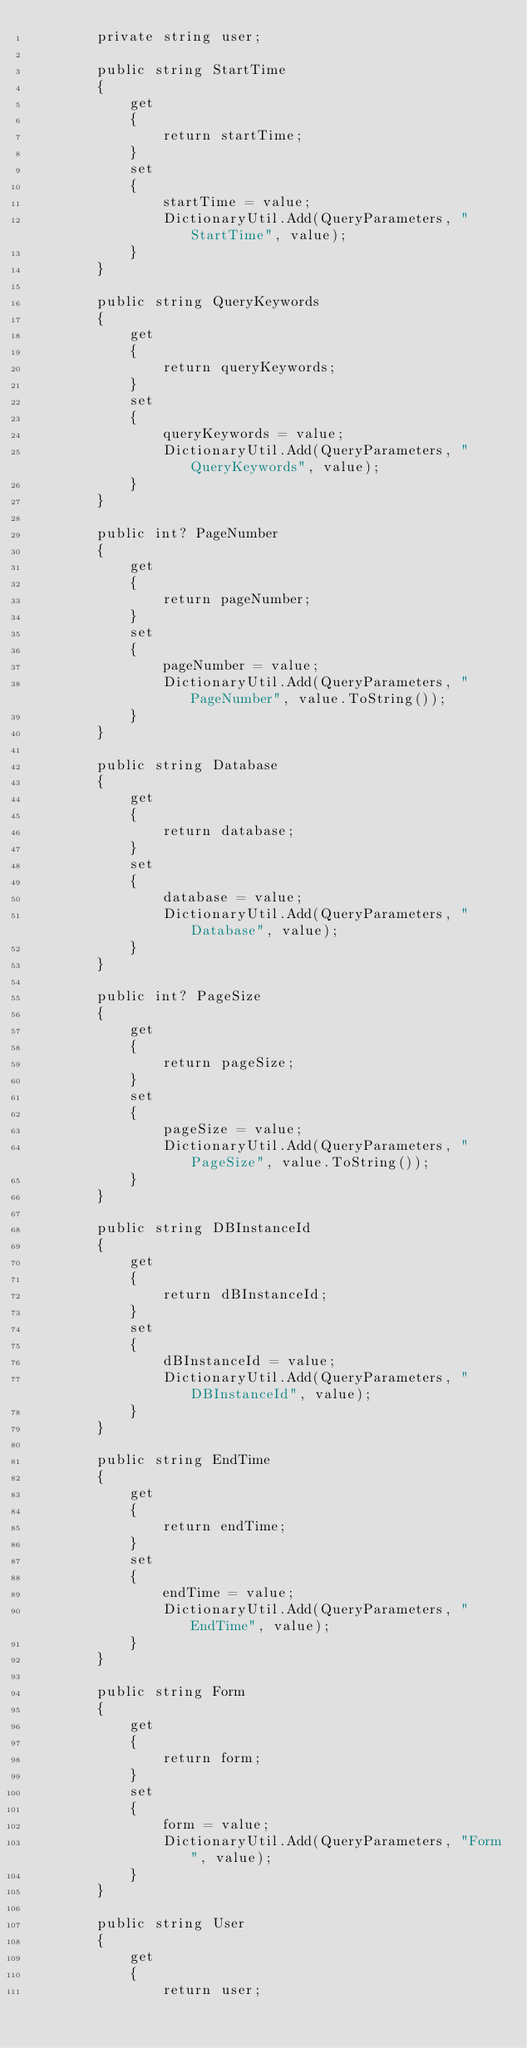<code> <loc_0><loc_0><loc_500><loc_500><_C#_>		private string user;

		public string StartTime
		{
			get
			{
				return startTime;
			}
			set	
			{
				startTime = value;
				DictionaryUtil.Add(QueryParameters, "StartTime", value);
			}
		}

		public string QueryKeywords
		{
			get
			{
				return queryKeywords;
			}
			set	
			{
				queryKeywords = value;
				DictionaryUtil.Add(QueryParameters, "QueryKeywords", value);
			}
		}

		public int? PageNumber
		{
			get
			{
				return pageNumber;
			}
			set	
			{
				pageNumber = value;
				DictionaryUtil.Add(QueryParameters, "PageNumber", value.ToString());
			}
		}

		public string Database
		{
			get
			{
				return database;
			}
			set	
			{
				database = value;
				DictionaryUtil.Add(QueryParameters, "Database", value);
			}
		}

		public int? PageSize
		{
			get
			{
				return pageSize;
			}
			set	
			{
				pageSize = value;
				DictionaryUtil.Add(QueryParameters, "PageSize", value.ToString());
			}
		}

		public string DBInstanceId
		{
			get
			{
				return dBInstanceId;
			}
			set	
			{
				dBInstanceId = value;
				DictionaryUtil.Add(QueryParameters, "DBInstanceId", value);
			}
		}

		public string EndTime
		{
			get
			{
				return endTime;
			}
			set	
			{
				endTime = value;
				DictionaryUtil.Add(QueryParameters, "EndTime", value);
			}
		}

		public string Form
		{
			get
			{
				return form;
			}
			set	
			{
				form = value;
				DictionaryUtil.Add(QueryParameters, "Form", value);
			}
		}

		public string User
		{
			get
			{
				return user;</code> 